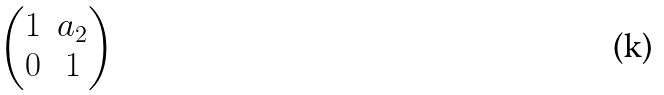<formula> <loc_0><loc_0><loc_500><loc_500>\begin{pmatrix} 1 & a _ { 2 } \\ 0 & 1 \end{pmatrix}</formula> 